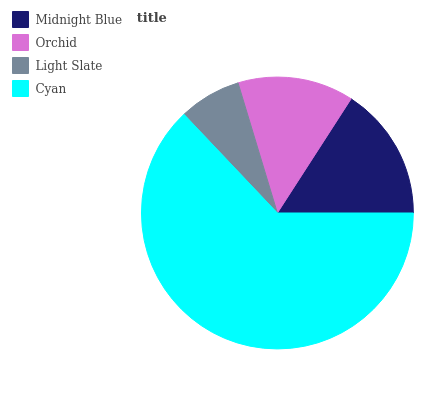Is Light Slate the minimum?
Answer yes or no. Yes. Is Cyan the maximum?
Answer yes or no. Yes. Is Orchid the minimum?
Answer yes or no. No. Is Orchid the maximum?
Answer yes or no. No. Is Midnight Blue greater than Orchid?
Answer yes or no. Yes. Is Orchid less than Midnight Blue?
Answer yes or no. Yes. Is Orchid greater than Midnight Blue?
Answer yes or no. No. Is Midnight Blue less than Orchid?
Answer yes or no. No. Is Midnight Blue the high median?
Answer yes or no. Yes. Is Orchid the low median?
Answer yes or no. Yes. Is Cyan the high median?
Answer yes or no. No. Is Midnight Blue the low median?
Answer yes or no. No. 